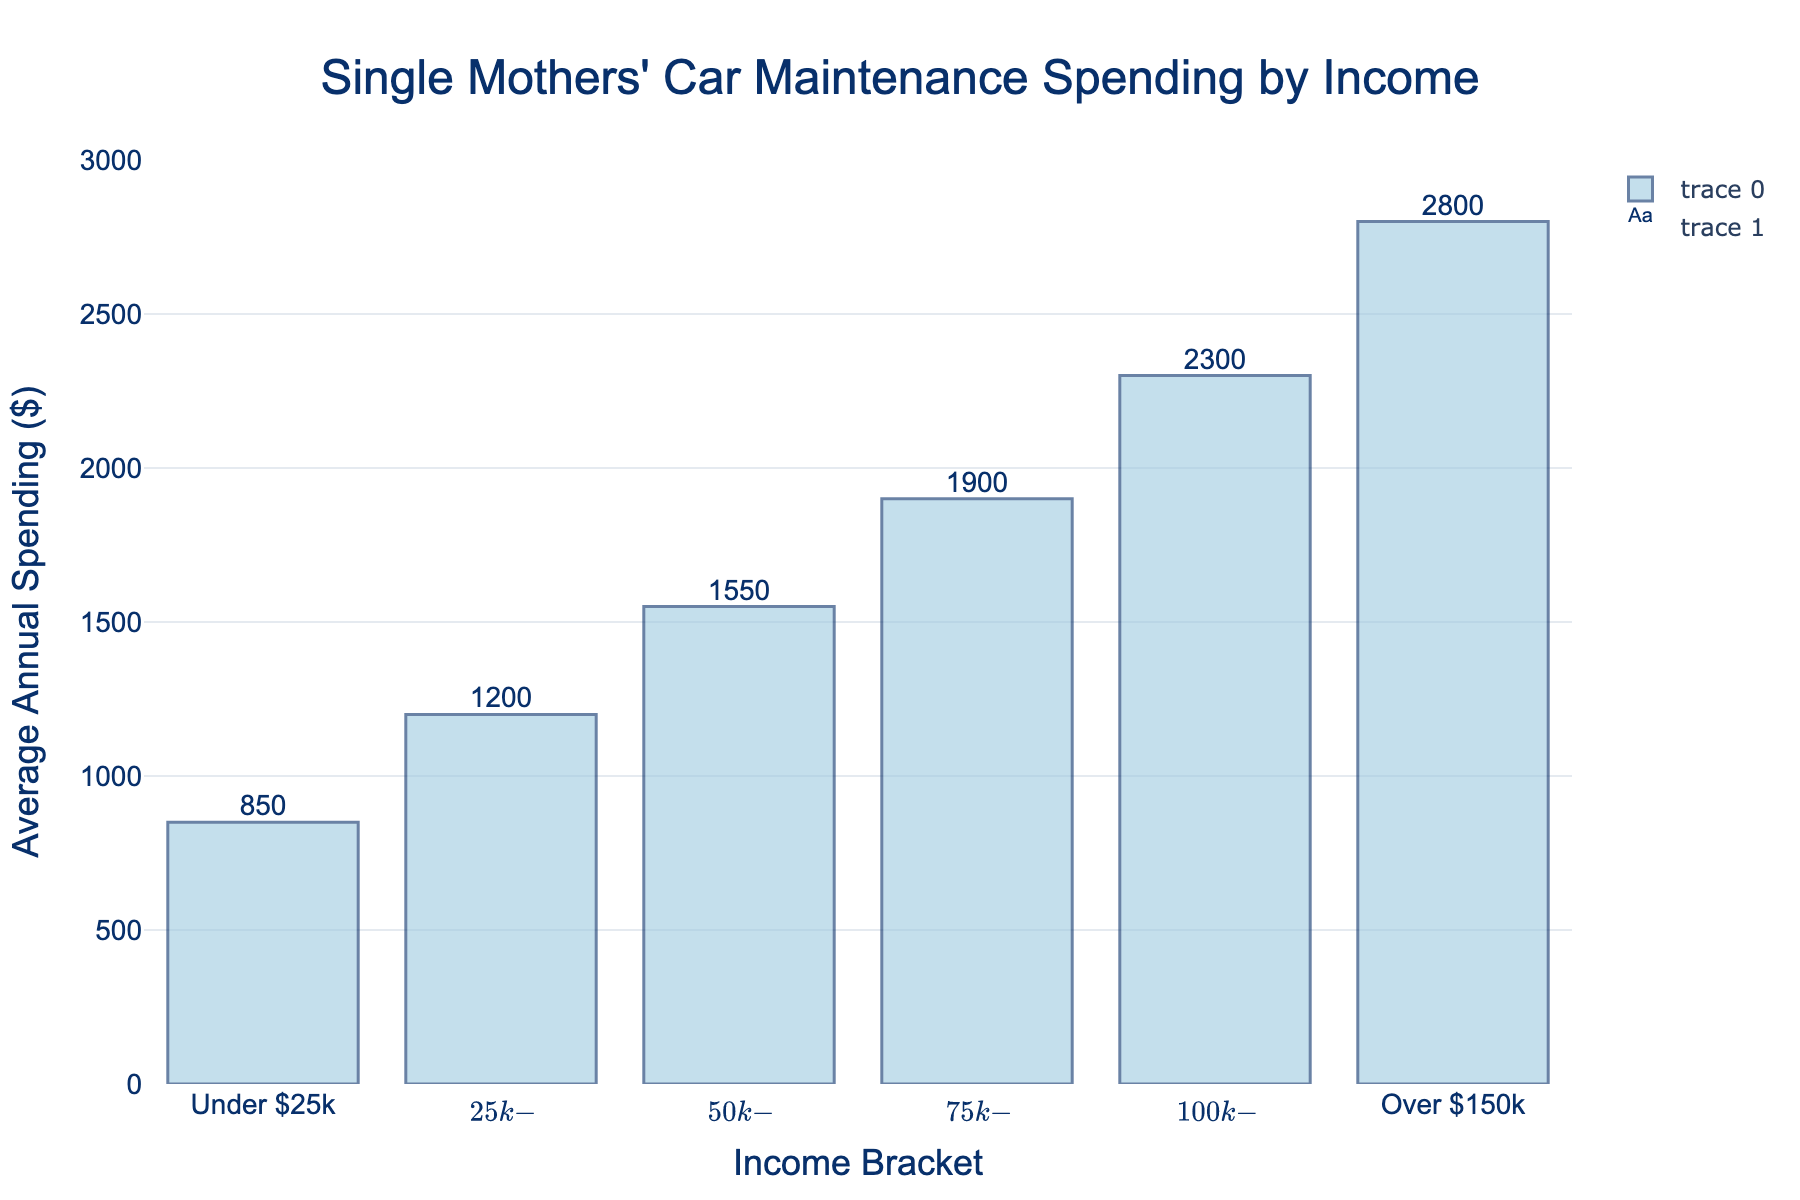What is the average annual spending in the $50k-$75k income bracket? Look at the bar corresponding to the $50k-$75k income bracket on the x-axis, then read the height of the bar to get the average annual spending.
Answer: 1550 Which income bracket has the lowest average annual spending? Compare the heights of all the bars and identify the shortest one. The shortest bar corresponds to the "Under $25k" income bracket.
Answer: Under $25k What is the difference in average annual spending between the $100k-$150k and $25k-$50k income brackets? Find the heights of the bars for both the $100k-$150k and $25k-$50k income brackets. Then, subtract the average annual spending of the $25k-$50k bracket from that of the $100k-$150k bracket: 2300 - 1200.
Answer: 1100 What is the range of average annual spending across all income brackets? Identify the highest and lowest spending values. The highest spending is for the "Over $150k" bracket (2800), and the lowest is the "Under $25k" bracket (850). Subtract the lowest from the highest: 2800 - 850.
Answer: 1950 Which income bracket has the second highest average annual spending? Compare the heights of all the bars, find the highest one, and then locate the next highest bar. The second highest bar corresponds to the "$100k-$150k" income bracket.
Answer: $100k-$150k How much more do single mothers earning over $150k spend on car maintenance compared to those earning under $25k? Find the heights of the bars for the "Over $150k" and "Under $25k" income brackets. Subtract the value of "Under $25k" from "Over $150k": 2800 - 850.
Answer: 1950 What is the total average annual spending for the income brackets $25k-$50k and $75k-$100k? Find the average annual spending for the $25k-$50k and $75k-$100k brackets. Then, add these values together: 1200 + 1900.
Answer: 3100 If a single mother’s income rises from $50k to $100k, what is the increase in her average annual spending on car maintenance? Determine the average annual spending for the $50k-$75k and $75k-$100k income brackets. Calculate the increase by subtracting the value for the $50k-$75k bracket from that of the $75k-$100k bracket: 1900 - 1550.
Answer: 350 Is the increase in average annual spending from the $25k-$50k to the $50k-$75k bracket greater than the increase from the $75k-$100k to the $100k-$150k bracket? Calculate the increase from $25k-$50k to $50k-$75k: 1550 - 1200. Calculate the increase from $75k-$100k to $100k-$150k: 2300 - 1900. Compare the two increases. 350 vs. 400, respectively.
Answer: No 